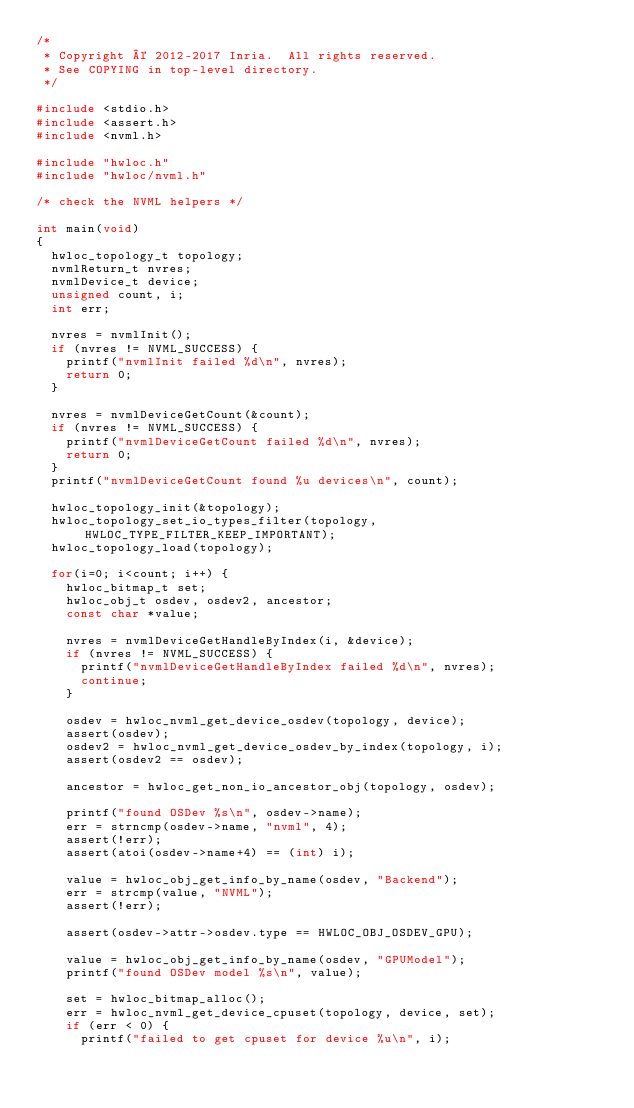Convert code to text. <code><loc_0><loc_0><loc_500><loc_500><_C_>/*
 * Copyright © 2012-2017 Inria.  All rights reserved.
 * See COPYING in top-level directory.
 */

#include <stdio.h>
#include <assert.h>
#include <nvml.h>

#include "hwloc.h"
#include "hwloc/nvml.h"

/* check the NVML helpers */

int main(void)
{
  hwloc_topology_t topology;
  nvmlReturn_t nvres;
  nvmlDevice_t device;
  unsigned count, i;
  int err;

  nvres = nvmlInit();
  if (nvres != NVML_SUCCESS) {
    printf("nvmlInit failed %d\n", nvres);
    return 0;
  }

  nvres = nvmlDeviceGetCount(&count);
  if (nvres != NVML_SUCCESS) {
    printf("nvmlDeviceGetCount failed %d\n", nvres);
    return 0;
  }
  printf("nvmlDeviceGetCount found %u devices\n", count);

  hwloc_topology_init(&topology);
  hwloc_topology_set_io_types_filter(topology, HWLOC_TYPE_FILTER_KEEP_IMPORTANT);
  hwloc_topology_load(topology);

  for(i=0; i<count; i++) {
    hwloc_bitmap_t set;
    hwloc_obj_t osdev, osdev2, ancestor;
    const char *value;

    nvres = nvmlDeviceGetHandleByIndex(i, &device);
    if (nvres != NVML_SUCCESS) {
      printf("nvmlDeviceGetHandleByIndex failed %d\n", nvres);
      continue;
    }

    osdev = hwloc_nvml_get_device_osdev(topology, device);
    assert(osdev);
    osdev2 = hwloc_nvml_get_device_osdev_by_index(topology, i);
    assert(osdev2 == osdev);

    ancestor = hwloc_get_non_io_ancestor_obj(topology, osdev);

    printf("found OSDev %s\n", osdev->name);
    err = strncmp(osdev->name, "nvml", 4);
    assert(!err);
    assert(atoi(osdev->name+4) == (int) i);

    value = hwloc_obj_get_info_by_name(osdev, "Backend");
    err = strcmp(value, "NVML");
    assert(!err);

    assert(osdev->attr->osdev.type == HWLOC_OBJ_OSDEV_GPU);

    value = hwloc_obj_get_info_by_name(osdev, "GPUModel");
    printf("found OSDev model %s\n", value);

    set = hwloc_bitmap_alloc();
    err = hwloc_nvml_get_device_cpuset(topology, device, set);
    if (err < 0) {
      printf("failed to get cpuset for device %u\n", i);</code> 